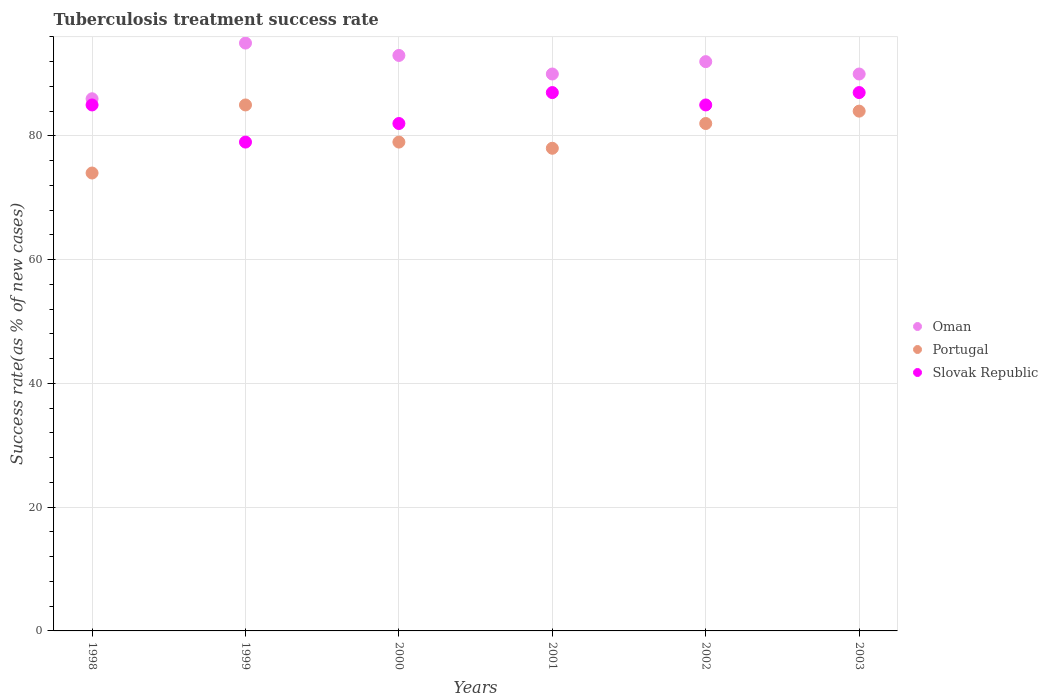How many different coloured dotlines are there?
Make the answer very short. 3. Is the number of dotlines equal to the number of legend labels?
Your answer should be very brief. Yes. What is the tuberculosis treatment success rate in Oman in 2002?
Your answer should be compact. 92. Across all years, what is the maximum tuberculosis treatment success rate in Oman?
Make the answer very short. 95. Across all years, what is the minimum tuberculosis treatment success rate in Slovak Republic?
Your answer should be compact. 79. In which year was the tuberculosis treatment success rate in Slovak Republic maximum?
Your response must be concise. 2001. In which year was the tuberculosis treatment success rate in Portugal minimum?
Make the answer very short. 1998. What is the total tuberculosis treatment success rate in Oman in the graph?
Provide a short and direct response. 546. What is the difference between the tuberculosis treatment success rate in Portugal in 2003 and the tuberculosis treatment success rate in Oman in 2001?
Make the answer very short. -6. What is the average tuberculosis treatment success rate in Oman per year?
Your response must be concise. 91. In how many years, is the tuberculosis treatment success rate in Portugal greater than 52 %?
Ensure brevity in your answer.  6. What is the ratio of the tuberculosis treatment success rate in Oman in 2000 to that in 2003?
Make the answer very short. 1.03. Is the difference between the tuberculosis treatment success rate in Slovak Republic in 2000 and 2002 greater than the difference between the tuberculosis treatment success rate in Oman in 2000 and 2002?
Offer a terse response. No. What is the difference between the highest and the lowest tuberculosis treatment success rate in Slovak Republic?
Make the answer very short. 8. In how many years, is the tuberculosis treatment success rate in Slovak Republic greater than the average tuberculosis treatment success rate in Slovak Republic taken over all years?
Offer a very short reply. 4. Is the sum of the tuberculosis treatment success rate in Oman in 1999 and 2002 greater than the maximum tuberculosis treatment success rate in Slovak Republic across all years?
Offer a very short reply. Yes. Does the tuberculosis treatment success rate in Portugal monotonically increase over the years?
Make the answer very short. No. How many years are there in the graph?
Provide a short and direct response. 6. What is the difference between two consecutive major ticks on the Y-axis?
Your answer should be compact. 20. Does the graph contain any zero values?
Your answer should be compact. No. What is the title of the graph?
Offer a terse response. Tuberculosis treatment success rate. What is the label or title of the Y-axis?
Make the answer very short. Success rate(as % of new cases). What is the Success rate(as % of new cases) in Portugal in 1998?
Provide a succinct answer. 74. What is the Success rate(as % of new cases) in Slovak Republic in 1999?
Your response must be concise. 79. What is the Success rate(as % of new cases) of Oman in 2000?
Provide a succinct answer. 93. What is the Success rate(as % of new cases) in Portugal in 2000?
Your answer should be very brief. 79. What is the Success rate(as % of new cases) of Slovak Republic in 2000?
Your answer should be compact. 82. What is the Success rate(as % of new cases) in Portugal in 2001?
Provide a succinct answer. 78. What is the Success rate(as % of new cases) in Oman in 2002?
Your response must be concise. 92. What is the Success rate(as % of new cases) in Portugal in 2002?
Your answer should be compact. 82. What is the Success rate(as % of new cases) in Slovak Republic in 2002?
Offer a very short reply. 85. What is the Success rate(as % of new cases) of Portugal in 2003?
Give a very brief answer. 84. What is the Success rate(as % of new cases) of Slovak Republic in 2003?
Your answer should be compact. 87. Across all years, what is the maximum Success rate(as % of new cases) in Portugal?
Your response must be concise. 85. Across all years, what is the minimum Success rate(as % of new cases) of Slovak Republic?
Keep it short and to the point. 79. What is the total Success rate(as % of new cases) in Oman in the graph?
Your answer should be compact. 546. What is the total Success rate(as % of new cases) of Portugal in the graph?
Offer a terse response. 482. What is the total Success rate(as % of new cases) of Slovak Republic in the graph?
Give a very brief answer. 505. What is the difference between the Success rate(as % of new cases) of Oman in 1998 and that in 1999?
Your answer should be very brief. -9. What is the difference between the Success rate(as % of new cases) of Portugal in 1998 and that in 2000?
Provide a succinct answer. -5. What is the difference between the Success rate(as % of new cases) in Oman in 1998 and that in 2002?
Your response must be concise. -6. What is the difference between the Success rate(as % of new cases) in Portugal in 1998 and that in 2003?
Your answer should be very brief. -10. What is the difference between the Success rate(as % of new cases) of Slovak Republic in 1999 and that in 2000?
Provide a succinct answer. -3. What is the difference between the Success rate(as % of new cases) in Oman in 1999 and that in 2001?
Offer a terse response. 5. What is the difference between the Success rate(as % of new cases) of Slovak Republic in 1999 and that in 2001?
Your answer should be compact. -8. What is the difference between the Success rate(as % of new cases) of Oman in 1999 and that in 2002?
Your response must be concise. 3. What is the difference between the Success rate(as % of new cases) in Portugal in 1999 and that in 2002?
Your answer should be compact. 3. What is the difference between the Success rate(as % of new cases) in Slovak Republic in 1999 and that in 2002?
Ensure brevity in your answer.  -6. What is the difference between the Success rate(as % of new cases) in Slovak Republic in 1999 and that in 2003?
Make the answer very short. -8. What is the difference between the Success rate(as % of new cases) of Portugal in 2000 and that in 2001?
Provide a short and direct response. 1. What is the difference between the Success rate(as % of new cases) of Portugal in 2000 and that in 2002?
Keep it short and to the point. -3. What is the difference between the Success rate(as % of new cases) of Slovak Republic in 2000 and that in 2002?
Offer a very short reply. -3. What is the difference between the Success rate(as % of new cases) in Oman in 2000 and that in 2003?
Your response must be concise. 3. What is the difference between the Success rate(as % of new cases) of Portugal in 2000 and that in 2003?
Provide a short and direct response. -5. What is the difference between the Success rate(as % of new cases) in Slovak Republic in 2001 and that in 2002?
Your answer should be very brief. 2. What is the difference between the Success rate(as % of new cases) in Oman in 2001 and that in 2003?
Give a very brief answer. 0. What is the difference between the Success rate(as % of new cases) in Portugal in 2001 and that in 2003?
Make the answer very short. -6. What is the difference between the Success rate(as % of new cases) of Oman in 2002 and that in 2003?
Provide a succinct answer. 2. What is the difference between the Success rate(as % of new cases) of Oman in 1998 and the Success rate(as % of new cases) of Slovak Republic in 1999?
Offer a terse response. 7. What is the difference between the Success rate(as % of new cases) of Oman in 1998 and the Success rate(as % of new cases) of Portugal in 2000?
Offer a terse response. 7. What is the difference between the Success rate(as % of new cases) of Portugal in 1998 and the Success rate(as % of new cases) of Slovak Republic in 2000?
Make the answer very short. -8. What is the difference between the Success rate(as % of new cases) of Oman in 1998 and the Success rate(as % of new cases) of Portugal in 2001?
Make the answer very short. 8. What is the difference between the Success rate(as % of new cases) of Oman in 1998 and the Success rate(as % of new cases) of Slovak Republic in 2001?
Provide a short and direct response. -1. What is the difference between the Success rate(as % of new cases) in Oman in 1998 and the Success rate(as % of new cases) in Slovak Republic in 2003?
Provide a short and direct response. -1. What is the difference between the Success rate(as % of new cases) in Portugal in 1998 and the Success rate(as % of new cases) in Slovak Republic in 2003?
Ensure brevity in your answer.  -13. What is the difference between the Success rate(as % of new cases) in Oman in 1999 and the Success rate(as % of new cases) in Slovak Republic in 2000?
Offer a terse response. 13. What is the difference between the Success rate(as % of new cases) in Portugal in 1999 and the Success rate(as % of new cases) in Slovak Republic in 2000?
Make the answer very short. 3. What is the difference between the Success rate(as % of new cases) in Oman in 1999 and the Success rate(as % of new cases) in Slovak Republic in 2002?
Provide a succinct answer. 10. What is the difference between the Success rate(as % of new cases) in Portugal in 1999 and the Success rate(as % of new cases) in Slovak Republic in 2002?
Your answer should be compact. 0. What is the difference between the Success rate(as % of new cases) of Portugal in 1999 and the Success rate(as % of new cases) of Slovak Republic in 2003?
Offer a terse response. -2. What is the difference between the Success rate(as % of new cases) in Oman in 2000 and the Success rate(as % of new cases) in Portugal in 2001?
Provide a succinct answer. 15. What is the difference between the Success rate(as % of new cases) in Portugal in 2000 and the Success rate(as % of new cases) in Slovak Republic in 2001?
Provide a succinct answer. -8. What is the difference between the Success rate(as % of new cases) in Oman in 2000 and the Success rate(as % of new cases) in Portugal in 2002?
Your answer should be very brief. 11. What is the difference between the Success rate(as % of new cases) of Portugal in 2000 and the Success rate(as % of new cases) of Slovak Republic in 2002?
Offer a terse response. -6. What is the difference between the Success rate(as % of new cases) of Oman in 2000 and the Success rate(as % of new cases) of Portugal in 2003?
Offer a very short reply. 9. What is the difference between the Success rate(as % of new cases) in Portugal in 2001 and the Success rate(as % of new cases) in Slovak Republic in 2002?
Your answer should be compact. -7. What is the difference between the Success rate(as % of new cases) in Oman in 2001 and the Success rate(as % of new cases) in Portugal in 2003?
Your answer should be compact. 6. What is the difference between the Success rate(as % of new cases) in Oman in 2001 and the Success rate(as % of new cases) in Slovak Republic in 2003?
Provide a succinct answer. 3. What is the difference between the Success rate(as % of new cases) in Portugal in 2001 and the Success rate(as % of new cases) in Slovak Republic in 2003?
Your response must be concise. -9. What is the difference between the Success rate(as % of new cases) in Oman in 2002 and the Success rate(as % of new cases) in Slovak Republic in 2003?
Your answer should be compact. 5. What is the difference between the Success rate(as % of new cases) of Portugal in 2002 and the Success rate(as % of new cases) of Slovak Republic in 2003?
Ensure brevity in your answer.  -5. What is the average Success rate(as % of new cases) of Oman per year?
Your answer should be very brief. 91. What is the average Success rate(as % of new cases) of Portugal per year?
Offer a very short reply. 80.33. What is the average Success rate(as % of new cases) in Slovak Republic per year?
Give a very brief answer. 84.17. In the year 1998, what is the difference between the Success rate(as % of new cases) of Oman and Success rate(as % of new cases) of Portugal?
Provide a short and direct response. 12. In the year 1998, what is the difference between the Success rate(as % of new cases) in Oman and Success rate(as % of new cases) in Slovak Republic?
Provide a succinct answer. 1. In the year 1999, what is the difference between the Success rate(as % of new cases) in Oman and Success rate(as % of new cases) in Portugal?
Your answer should be very brief. 10. In the year 1999, what is the difference between the Success rate(as % of new cases) in Oman and Success rate(as % of new cases) in Slovak Republic?
Ensure brevity in your answer.  16. In the year 2000, what is the difference between the Success rate(as % of new cases) of Oman and Success rate(as % of new cases) of Slovak Republic?
Keep it short and to the point. 11. In the year 2001, what is the difference between the Success rate(as % of new cases) of Oman and Success rate(as % of new cases) of Portugal?
Your answer should be compact. 12. In the year 2002, what is the difference between the Success rate(as % of new cases) of Oman and Success rate(as % of new cases) of Portugal?
Provide a succinct answer. 10. In the year 2002, what is the difference between the Success rate(as % of new cases) in Oman and Success rate(as % of new cases) in Slovak Republic?
Provide a short and direct response. 7. In the year 2003, what is the difference between the Success rate(as % of new cases) in Oman and Success rate(as % of new cases) in Portugal?
Your answer should be compact. 6. In the year 2003, what is the difference between the Success rate(as % of new cases) in Portugal and Success rate(as % of new cases) in Slovak Republic?
Offer a very short reply. -3. What is the ratio of the Success rate(as % of new cases) of Oman in 1998 to that in 1999?
Offer a very short reply. 0.91. What is the ratio of the Success rate(as % of new cases) of Portugal in 1998 to that in 1999?
Offer a terse response. 0.87. What is the ratio of the Success rate(as % of new cases) in Slovak Republic in 1998 to that in 1999?
Keep it short and to the point. 1.08. What is the ratio of the Success rate(as % of new cases) in Oman in 1998 to that in 2000?
Provide a succinct answer. 0.92. What is the ratio of the Success rate(as % of new cases) in Portugal in 1998 to that in 2000?
Your answer should be compact. 0.94. What is the ratio of the Success rate(as % of new cases) of Slovak Republic in 1998 to that in 2000?
Offer a terse response. 1.04. What is the ratio of the Success rate(as % of new cases) of Oman in 1998 to that in 2001?
Keep it short and to the point. 0.96. What is the ratio of the Success rate(as % of new cases) in Portugal in 1998 to that in 2001?
Make the answer very short. 0.95. What is the ratio of the Success rate(as % of new cases) in Slovak Republic in 1998 to that in 2001?
Your answer should be very brief. 0.98. What is the ratio of the Success rate(as % of new cases) in Oman in 1998 to that in 2002?
Ensure brevity in your answer.  0.93. What is the ratio of the Success rate(as % of new cases) of Portugal in 1998 to that in 2002?
Ensure brevity in your answer.  0.9. What is the ratio of the Success rate(as % of new cases) in Oman in 1998 to that in 2003?
Provide a succinct answer. 0.96. What is the ratio of the Success rate(as % of new cases) in Portugal in 1998 to that in 2003?
Make the answer very short. 0.88. What is the ratio of the Success rate(as % of new cases) of Slovak Republic in 1998 to that in 2003?
Provide a short and direct response. 0.98. What is the ratio of the Success rate(as % of new cases) of Oman in 1999 to that in 2000?
Offer a terse response. 1.02. What is the ratio of the Success rate(as % of new cases) in Portugal in 1999 to that in 2000?
Provide a succinct answer. 1.08. What is the ratio of the Success rate(as % of new cases) of Slovak Republic in 1999 to that in 2000?
Provide a succinct answer. 0.96. What is the ratio of the Success rate(as % of new cases) in Oman in 1999 to that in 2001?
Your answer should be very brief. 1.06. What is the ratio of the Success rate(as % of new cases) of Portugal in 1999 to that in 2001?
Your answer should be compact. 1.09. What is the ratio of the Success rate(as % of new cases) of Slovak Republic in 1999 to that in 2001?
Ensure brevity in your answer.  0.91. What is the ratio of the Success rate(as % of new cases) in Oman in 1999 to that in 2002?
Keep it short and to the point. 1.03. What is the ratio of the Success rate(as % of new cases) of Portugal in 1999 to that in 2002?
Provide a short and direct response. 1.04. What is the ratio of the Success rate(as % of new cases) in Slovak Republic in 1999 to that in 2002?
Offer a very short reply. 0.93. What is the ratio of the Success rate(as % of new cases) in Oman in 1999 to that in 2003?
Keep it short and to the point. 1.06. What is the ratio of the Success rate(as % of new cases) in Portugal in 1999 to that in 2003?
Provide a short and direct response. 1.01. What is the ratio of the Success rate(as % of new cases) of Slovak Republic in 1999 to that in 2003?
Offer a terse response. 0.91. What is the ratio of the Success rate(as % of new cases) in Portugal in 2000 to that in 2001?
Offer a terse response. 1.01. What is the ratio of the Success rate(as % of new cases) of Slovak Republic in 2000 to that in 2001?
Your answer should be compact. 0.94. What is the ratio of the Success rate(as % of new cases) in Oman in 2000 to that in 2002?
Your answer should be very brief. 1.01. What is the ratio of the Success rate(as % of new cases) of Portugal in 2000 to that in 2002?
Your answer should be very brief. 0.96. What is the ratio of the Success rate(as % of new cases) in Slovak Republic in 2000 to that in 2002?
Your response must be concise. 0.96. What is the ratio of the Success rate(as % of new cases) of Oman in 2000 to that in 2003?
Offer a terse response. 1.03. What is the ratio of the Success rate(as % of new cases) in Portugal in 2000 to that in 2003?
Your answer should be compact. 0.94. What is the ratio of the Success rate(as % of new cases) in Slovak Republic in 2000 to that in 2003?
Offer a very short reply. 0.94. What is the ratio of the Success rate(as % of new cases) of Oman in 2001 to that in 2002?
Your answer should be compact. 0.98. What is the ratio of the Success rate(as % of new cases) of Portugal in 2001 to that in 2002?
Keep it short and to the point. 0.95. What is the ratio of the Success rate(as % of new cases) in Slovak Republic in 2001 to that in 2002?
Your answer should be very brief. 1.02. What is the ratio of the Success rate(as % of new cases) in Oman in 2001 to that in 2003?
Offer a terse response. 1. What is the ratio of the Success rate(as % of new cases) in Slovak Republic in 2001 to that in 2003?
Make the answer very short. 1. What is the ratio of the Success rate(as % of new cases) of Oman in 2002 to that in 2003?
Offer a terse response. 1.02. What is the ratio of the Success rate(as % of new cases) in Portugal in 2002 to that in 2003?
Keep it short and to the point. 0.98. What is the difference between the highest and the second highest Success rate(as % of new cases) of Slovak Republic?
Your response must be concise. 0. What is the difference between the highest and the lowest Success rate(as % of new cases) of Slovak Republic?
Provide a short and direct response. 8. 